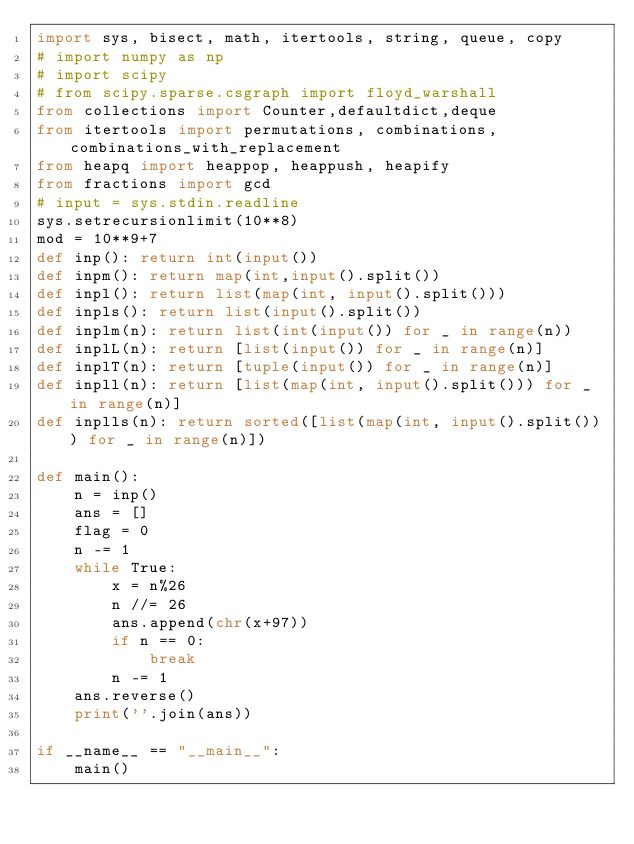<code> <loc_0><loc_0><loc_500><loc_500><_Python_>import sys, bisect, math, itertools, string, queue, copy
# import numpy as np
# import scipy
# from scipy.sparse.csgraph import floyd_warshall
from collections import Counter,defaultdict,deque
from itertools import permutations, combinations, combinations_with_replacement
from heapq import heappop, heappush, heapify
from fractions import gcd
# input = sys.stdin.readline
sys.setrecursionlimit(10**8)
mod = 10**9+7
def inp(): return int(input())
def inpm(): return map(int,input().split())
def inpl(): return list(map(int, input().split()))
def inpls(): return list(input().split())
def inplm(n): return list(int(input()) for _ in range(n))
def inplL(n): return [list(input()) for _ in range(n)]
def inplT(n): return [tuple(input()) for _ in range(n)]
def inpll(n): return [list(map(int, input().split())) for _ in range(n)]
def inplls(n): return sorted([list(map(int, input().split())) for _ in range(n)])

def main():
    n = inp()
    ans = []
    flag = 0
    n -= 1
    while True:
        x = n%26
        n //= 26
        ans.append(chr(x+97))
        if n == 0:
            break
        n -= 1
    ans.reverse()
    print(''.join(ans))
    
if __name__ == "__main__":
    main()</code> 